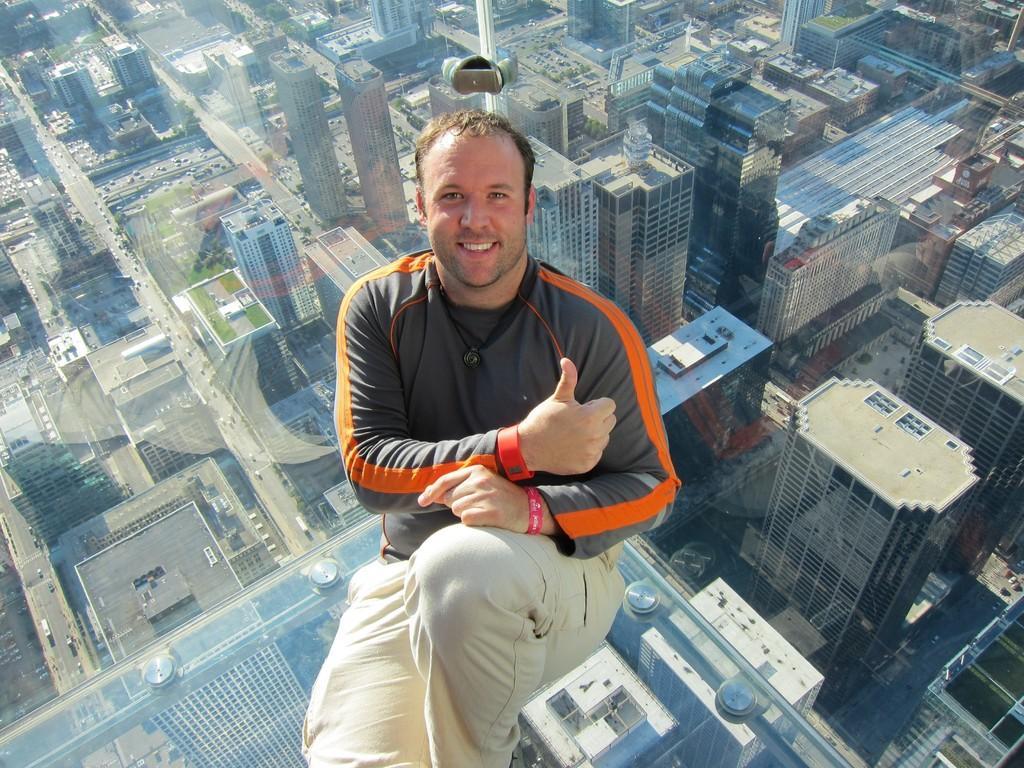Please provide a concise description of this image. In this picture we can see a man, he is smiling, in the background we can see few buildings. 